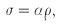<formula> <loc_0><loc_0><loc_500><loc_500>\sigma = \alpha \rho ,</formula> 